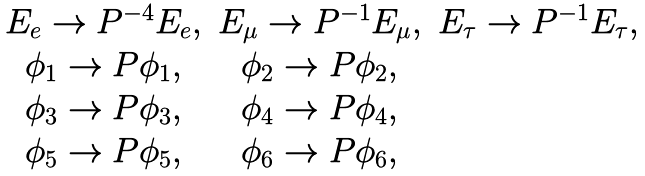Convert formula to latex. <formula><loc_0><loc_0><loc_500><loc_500>\begin{matrix} E _ { e } \rightarrow P ^ { - 4 } E _ { e } , & E _ { \mu } \rightarrow P ^ { - 1 } E _ { \mu } , & E _ { \tau } \rightarrow P ^ { - 1 } E _ { \tau } , \\ \phi _ { 1 } \rightarrow P \phi _ { 1 } , & \phi _ { 2 } \rightarrow P \phi _ { 2 } , \\ \phi _ { 3 } \rightarrow P \phi _ { 3 } , & \phi _ { 4 } \rightarrow P \phi _ { 4 } , \\ \phi _ { 5 } \rightarrow P \phi _ { 5 } , & \phi _ { 6 } \rightarrow P \phi _ { 6 } , \end{matrix}</formula> 